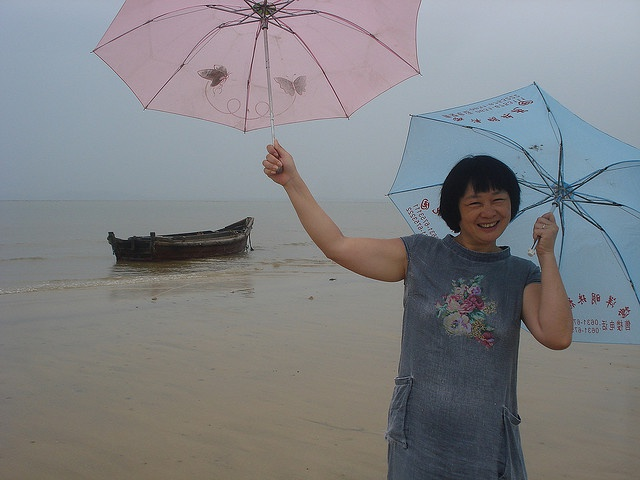Describe the objects in this image and their specific colors. I can see people in darkgray, gray, black, and darkblue tones, umbrella in darkgray, gray, and pink tones, umbrella in darkgray and gray tones, and boat in darkgray, black, and gray tones in this image. 